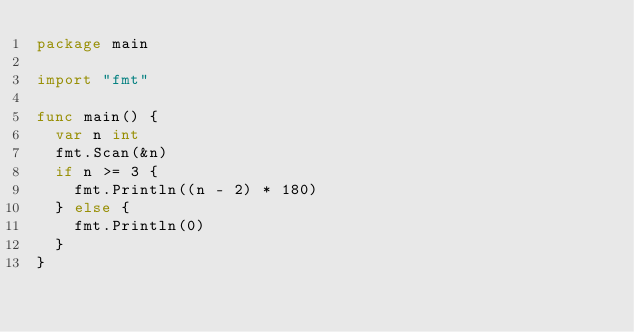Convert code to text. <code><loc_0><loc_0><loc_500><loc_500><_Go_>package main

import "fmt"

func main() {
	var n int
	fmt.Scan(&n)
	if n >= 3 {
		fmt.Println((n - 2) * 180)
	} else {
		fmt.Println(0)
	}
}</code> 